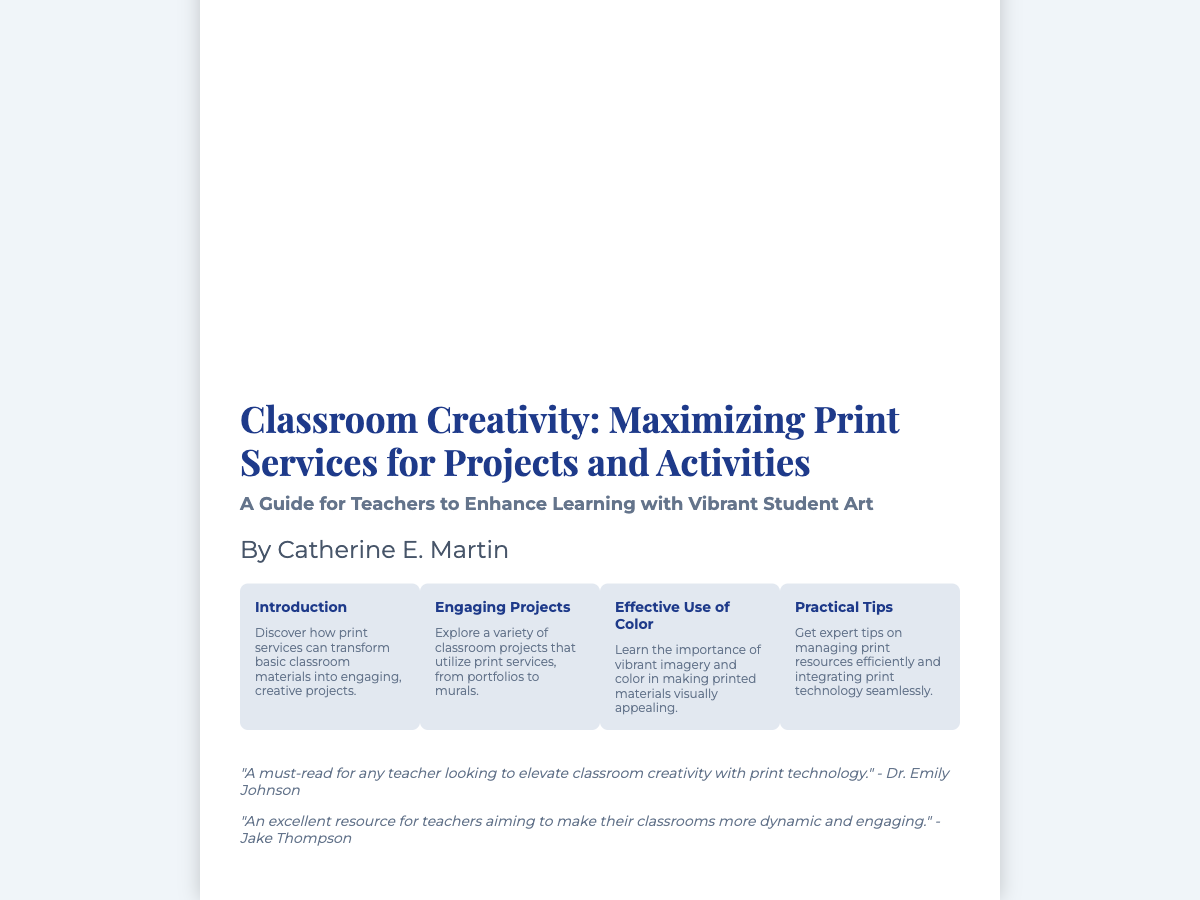what is the title of the book? The title of the book is clearly mentioned in the document for easy retrieval.
Answer: Classroom Creativity: Maximizing Print Services for Projects and Activities who is the author of the book? The author of the book is listed prominently in the author section of the content.
Answer: Catherine E. Martin what is the focus of the book? The focus of the book is stated in the subtitle, providing insight into the intended audience and purpose.
Answer: A Guide for Teachers to Enhance Learning with Vibrant Student Art how many key aspects are presented in the book cover? The document lists a specific number of key aspects that summarize the main topics covered in the book.
Answer: Four which aspect covers managing print resources? One of the aspects is dedicated to practical advice on resource management, indicating its importance.
Answer: Practical Tips what type of projects does the book explore? The document specifies the nature of the projects examined in relation to print services.
Answer: Classroom projects how are print services characterized in the introductory aspect? The introductory aspect provides a concise overview of the role of print services in classroom creativity.
Answer: Transform basic classroom materials into engaging, creative projects what is the color theme of the book cover? The color theme can be inferred from the overall design choices mentioned in the document.
Answer: Vibrant and colorful 